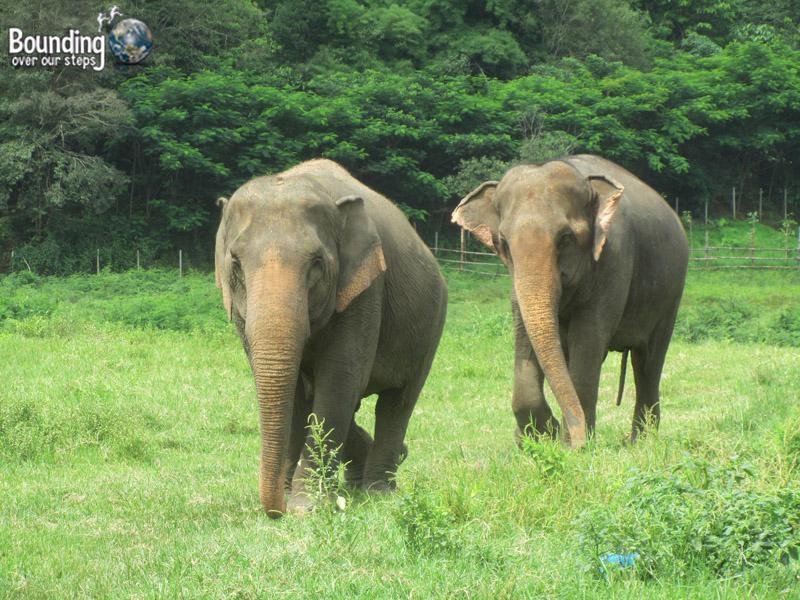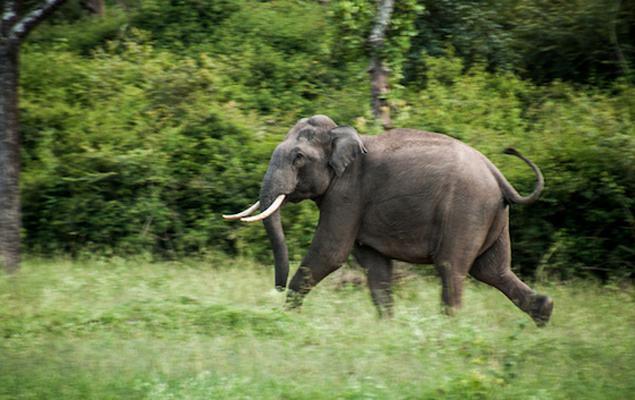The first image is the image on the left, the second image is the image on the right. Analyze the images presented: Is the assertion "There is one elephant in each image." valid? Answer yes or no. No. The first image is the image on the left, the second image is the image on the right. Evaluate the accuracy of this statement regarding the images: "There are more elephants in the image on the left.". Is it true? Answer yes or no. Yes. 